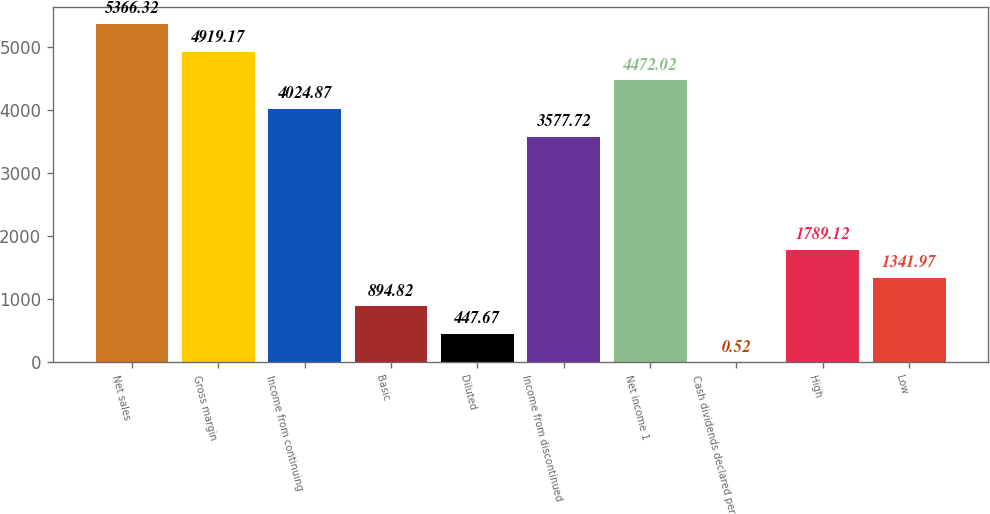Convert chart to OTSL. <chart><loc_0><loc_0><loc_500><loc_500><bar_chart><fcel>Net sales<fcel>Gross margin<fcel>Income from continuing<fcel>Basic<fcel>Diluted<fcel>Income from discontinued<fcel>Net income 1<fcel>Cash dividends declared per<fcel>High<fcel>Low<nl><fcel>5366.32<fcel>4919.17<fcel>4024.87<fcel>894.82<fcel>447.67<fcel>3577.72<fcel>4472.02<fcel>0.52<fcel>1789.12<fcel>1341.97<nl></chart> 